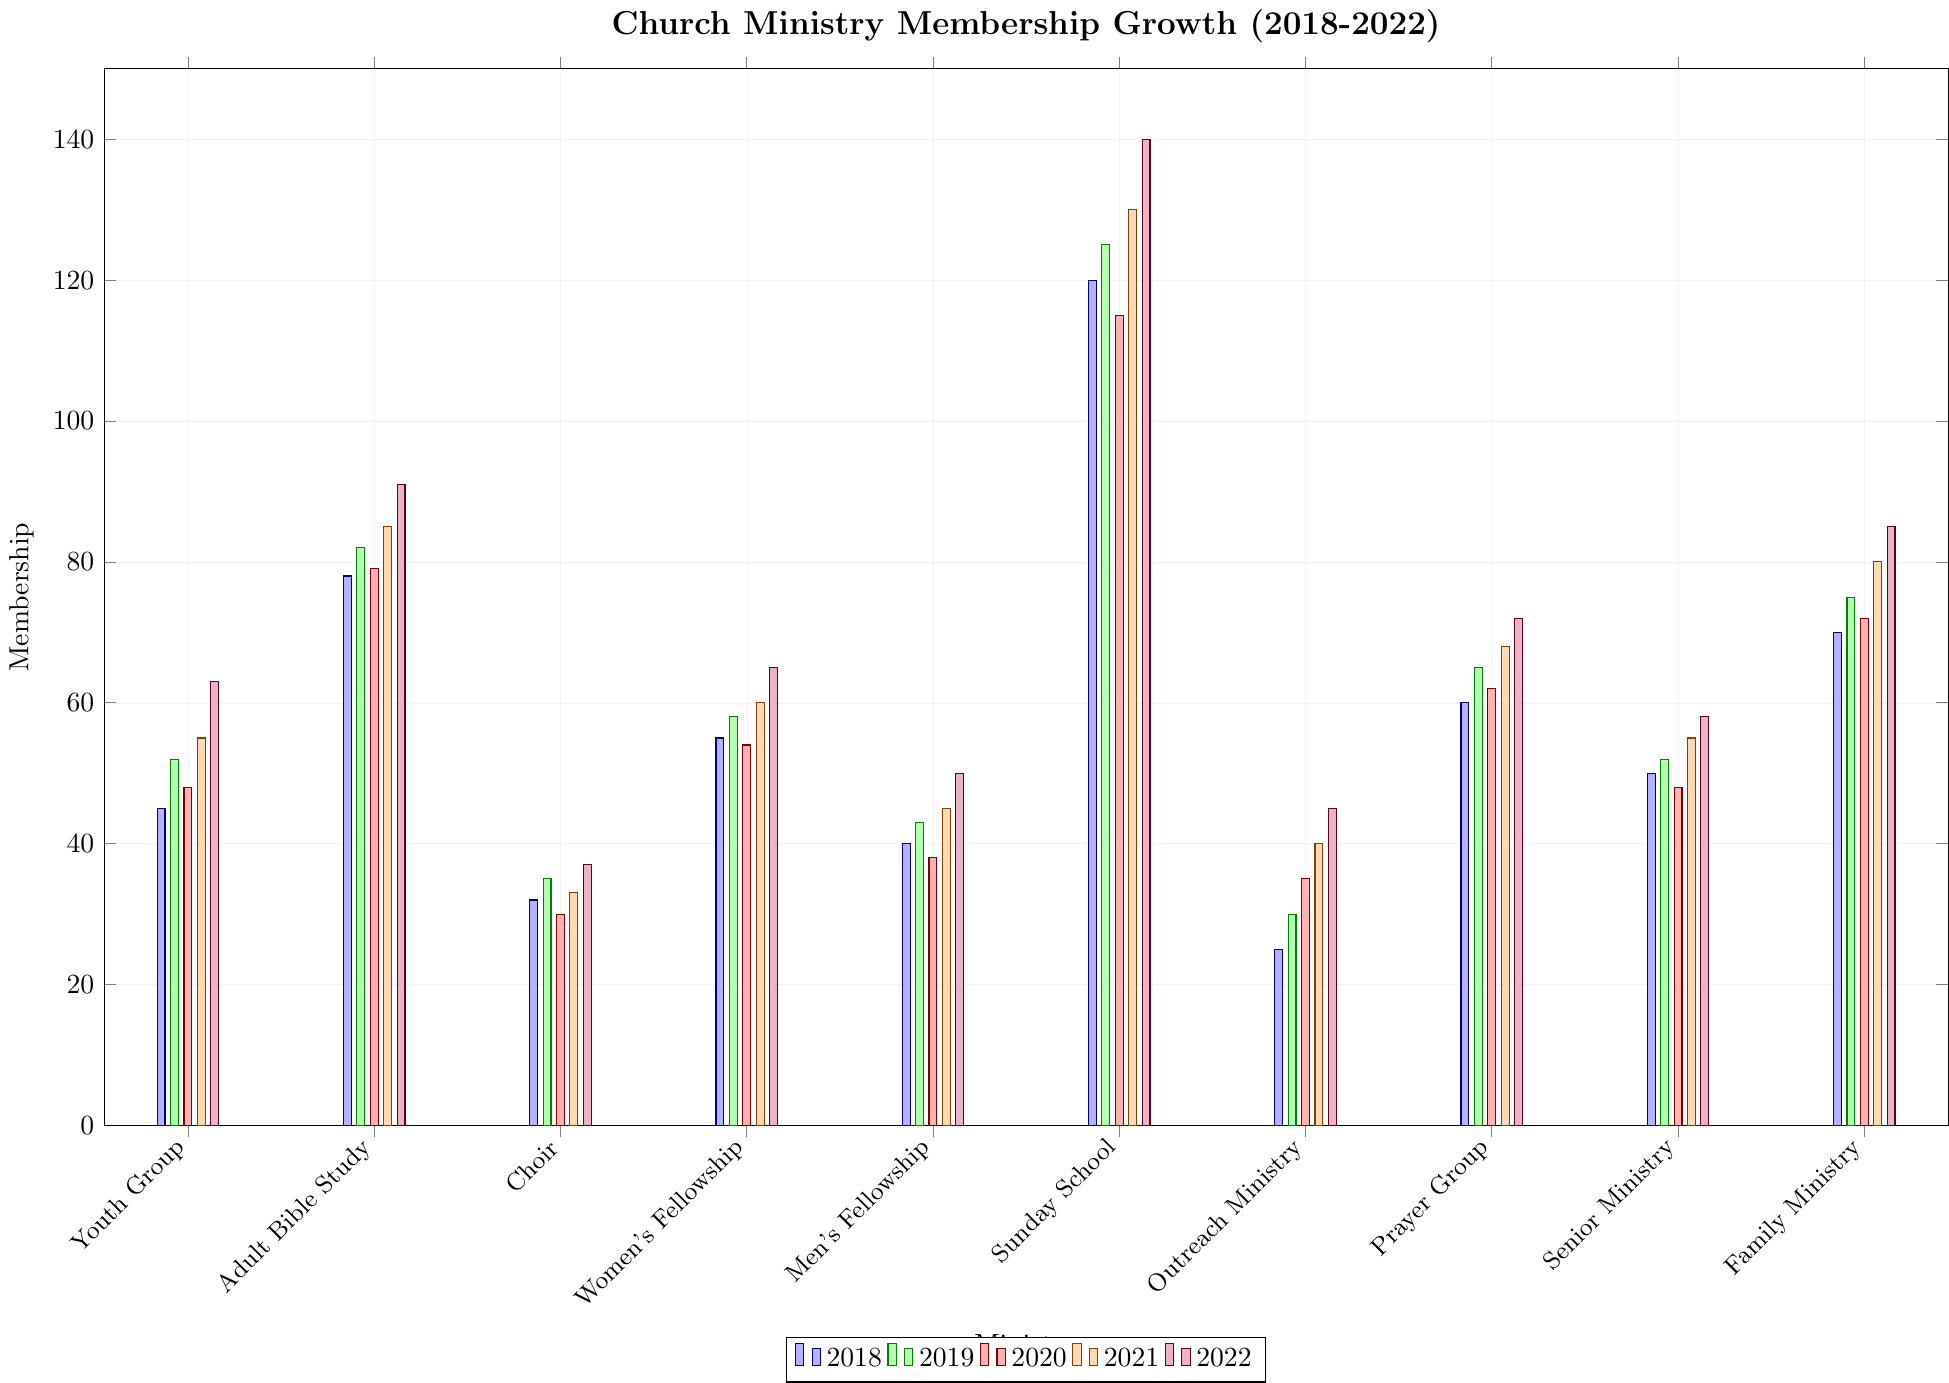How has the membership in the Youth Group changed from 2018 to 2022? First, identify the membership numbers for the Youth Group in 2018 and 2022, which are 45 and 63, respectively. Then calculate the change by subtracting the 2018 value from the 2022 value: 63 - 45 = 18.
Answer: Increased by 18 Which ministry had the highest membership in 2022? Locate the bars for 2022 and compare their heights. The tallest bar for 2022 corresponds to Sunday School, with a membership of 140.
Answer: Sunday School Between Men's Fellowship and Women's Fellowship, which ministry showed greater growth from 2018 to 2022? Identify the membership values for Men's Fellowship in 2018 and 2022: 40 and 50, respectively. Calculate the growth: 50 - 40 = 10. Do the same for Women's Fellowship, which grew from 55 to 65, resulting in a growth of 10.
Answer: Both showed equal growth What is the total membership across all ministries in 2021? Add the membership numbers for each ministry in 2021: 55 + 85 + 33 + 60 + 45 + 130 + 40 + 68 + 55 + 80 = 651.
Answer: 651 Which ministry had a decrease in membership from 2019 to 2020, and by how much? Look at the membership numbers for each ministry for the years 2019 and 2020. The Choir decreased from 35 to 30, resulting in a decrease of 5.
Answer: Choir, decreased by 5 What is the average membership for Family Ministry over the five years? First, sum the memberships for Family Ministry for each year: 70 + 75 + 72 + 80 + 85 = 382. Then divide by 5: 382 / 5 = 76.4.
Answer: 76.4 Which ministry saw the most consistent growth over the five years? Observe the bars for consistency in growth without any decreases over the years. Outreach Ministry showed steady growth from 25 in 2018 to 45 in 2022.
Answer: Outreach Ministry How much did the membership of the Adult Bible Study change from 2018 to 2021? Identify the membership numbers for Adult Bible Study in 2018 and 2021, which are 78 and 85, respectively. Calculate the change by subtracting the 2018 number from the 2021 number: 85 - 78 = 7.
Answer: Increased by 7 